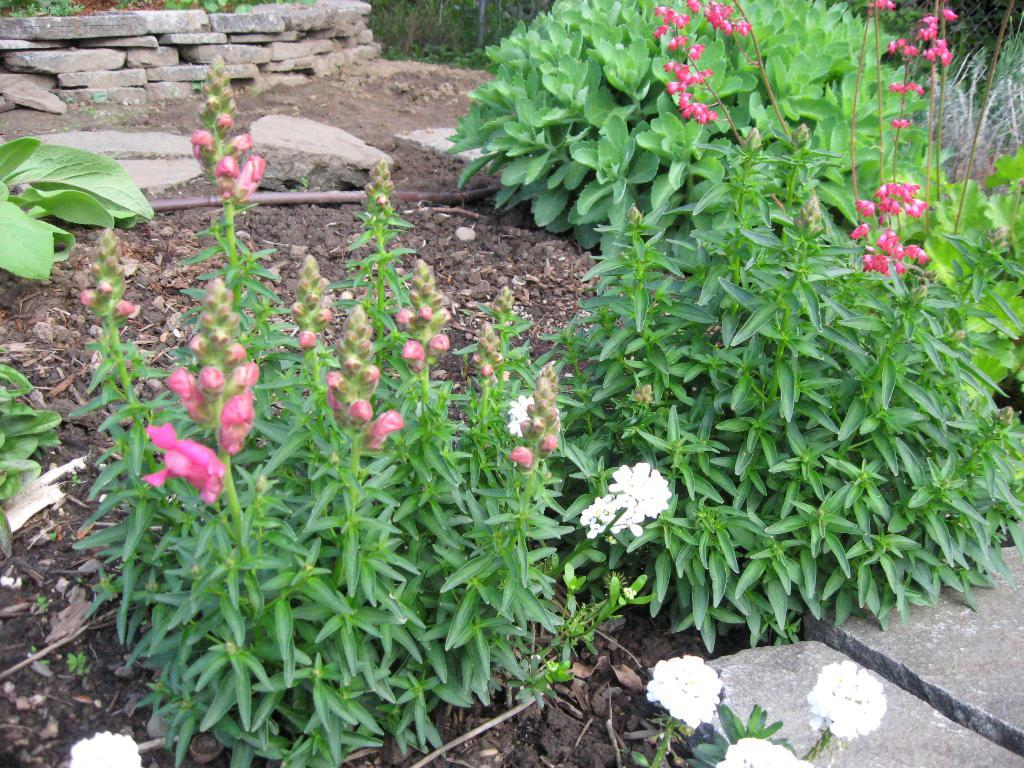What type of living organisms can be seen in the image? Plants and flowers are visible in the image. What colors are the flowers in the image? The flowers are pink and white in color. What type of material is visible in the image? There is soil, wooden pieces, and stones visible in the image. How many letters are hidden in the stones in the image? There are no letters hidden in the stones in the image; the stones are just stones. 